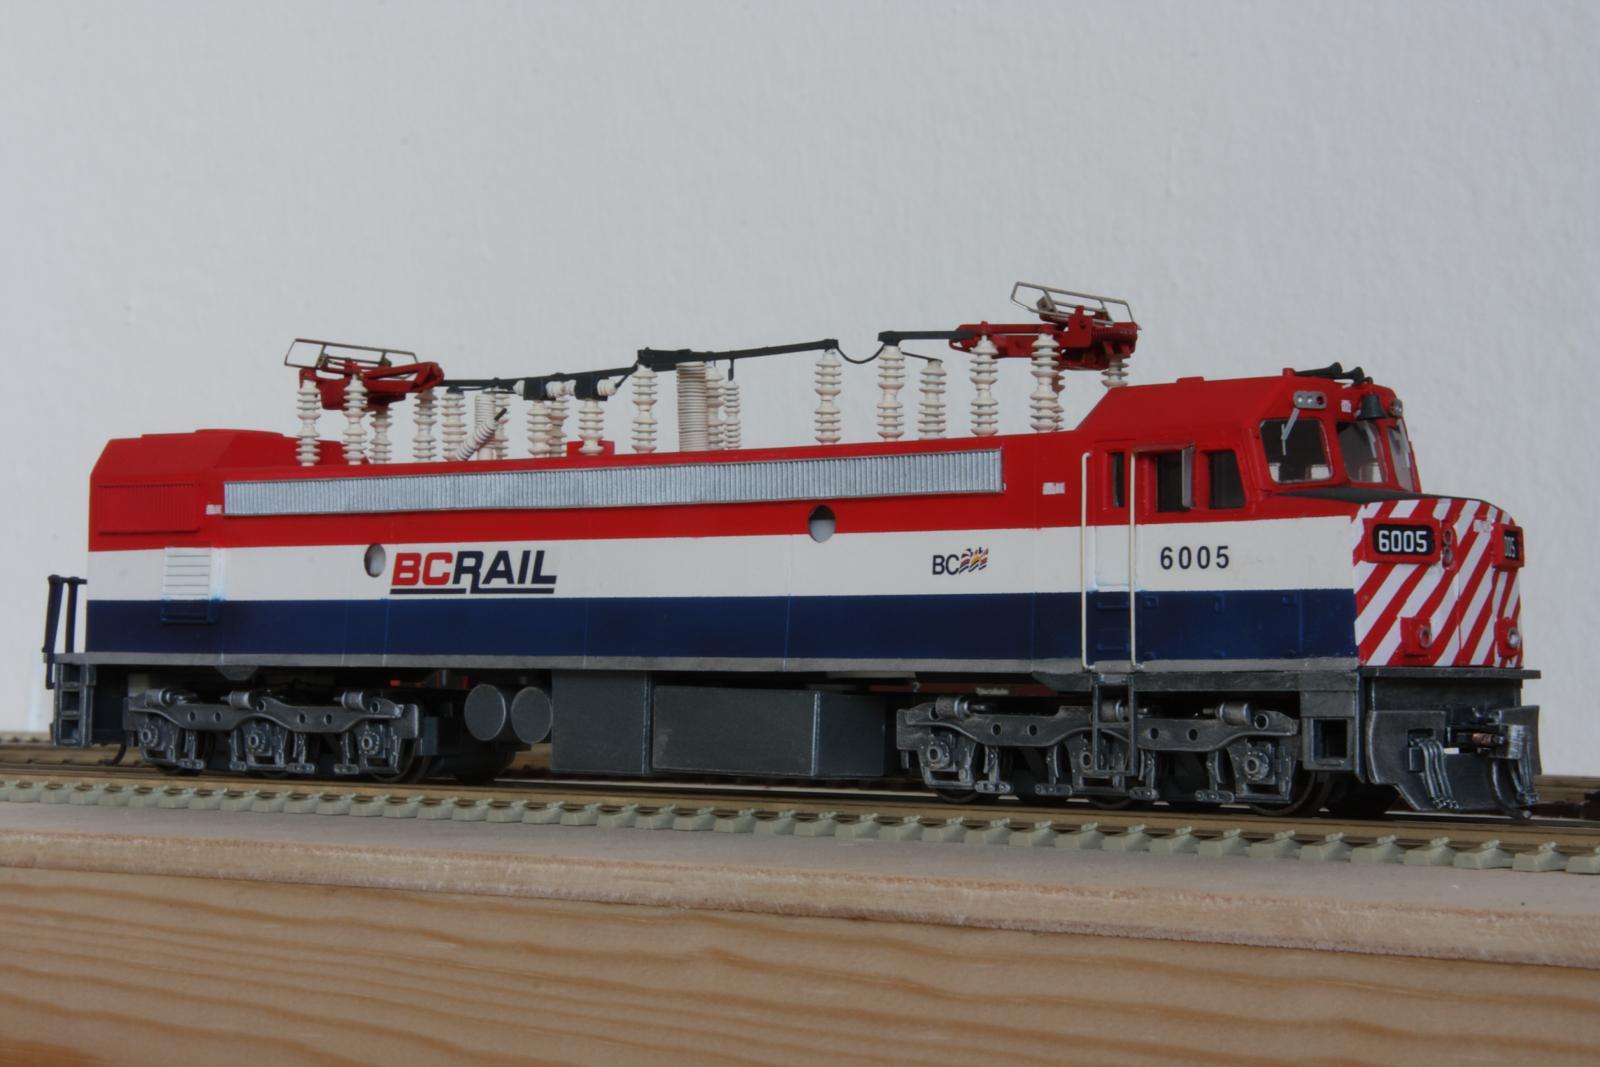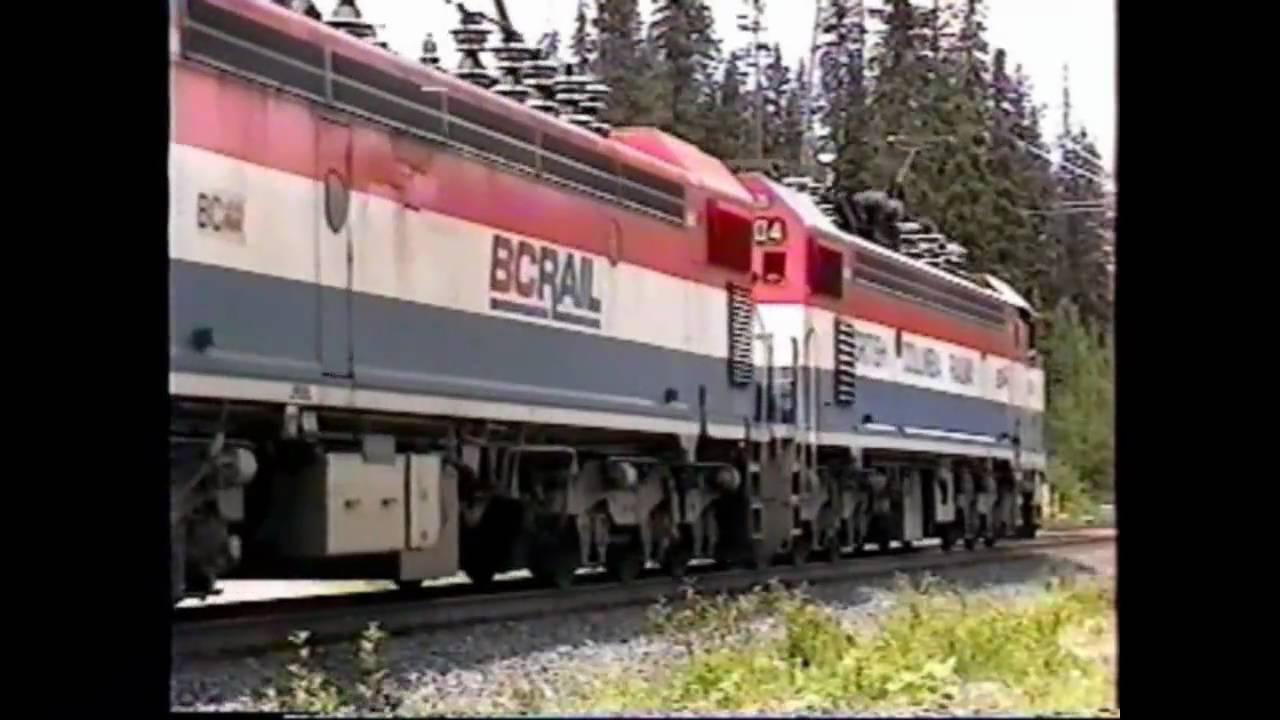The first image is the image on the left, the second image is the image on the right. Given the left and right images, does the statement "Both trains are red, white, and blue." hold true? Answer yes or no. Yes. The first image is the image on the left, the second image is the image on the right. Given the left and right images, does the statement "Each image shows a red-topped train with white and blue stripes running horizontally along the side." hold true? Answer yes or no. Yes. 